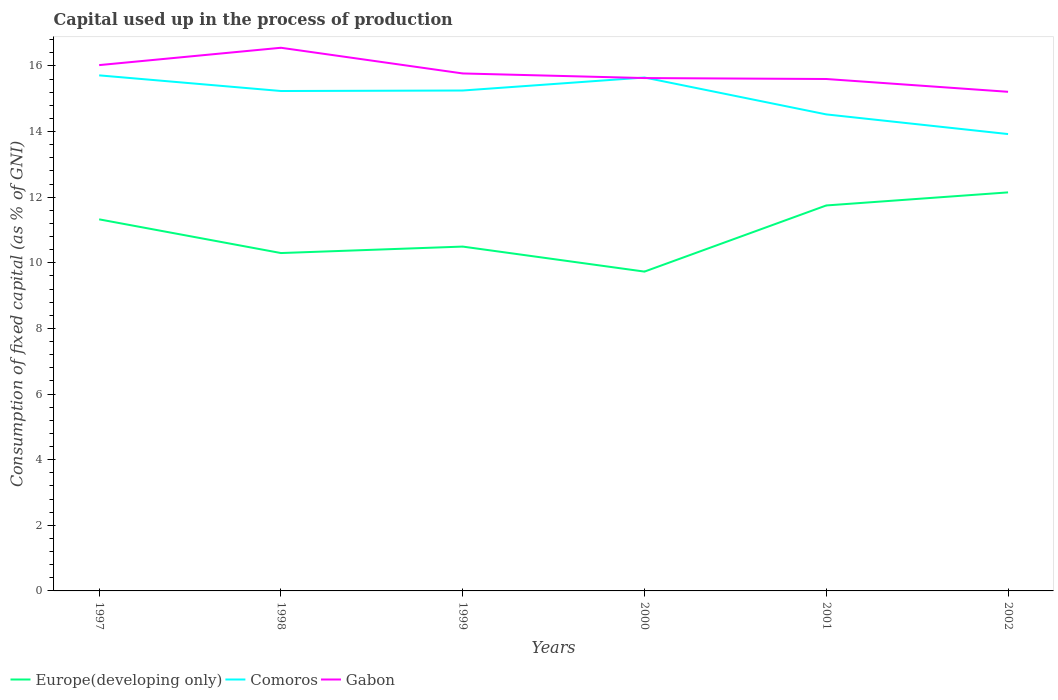Does the line corresponding to Europe(developing only) intersect with the line corresponding to Comoros?
Make the answer very short. No. Is the number of lines equal to the number of legend labels?
Provide a succinct answer. Yes. Across all years, what is the maximum capital used up in the process of production in Comoros?
Provide a short and direct response. 13.93. What is the total capital used up in the process of production in Europe(developing only) in the graph?
Provide a succinct answer. 0.57. What is the difference between the highest and the second highest capital used up in the process of production in Europe(developing only)?
Keep it short and to the point. 2.41. What is the difference between two consecutive major ticks on the Y-axis?
Your answer should be very brief. 2. Are the values on the major ticks of Y-axis written in scientific E-notation?
Your answer should be very brief. No. What is the title of the graph?
Keep it short and to the point. Capital used up in the process of production. What is the label or title of the Y-axis?
Give a very brief answer. Consumption of fixed capital (as % of GNI). What is the Consumption of fixed capital (as % of GNI) of Europe(developing only) in 1997?
Provide a succinct answer. 11.33. What is the Consumption of fixed capital (as % of GNI) in Comoros in 1997?
Offer a very short reply. 15.71. What is the Consumption of fixed capital (as % of GNI) of Gabon in 1997?
Offer a very short reply. 16.03. What is the Consumption of fixed capital (as % of GNI) of Europe(developing only) in 1998?
Make the answer very short. 10.3. What is the Consumption of fixed capital (as % of GNI) in Comoros in 1998?
Ensure brevity in your answer.  15.24. What is the Consumption of fixed capital (as % of GNI) in Gabon in 1998?
Offer a very short reply. 16.56. What is the Consumption of fixed capital (as % of GNI) of Europe(developing only) in 1999?
Your response must be concise. 10.5. What is the Consumption of fixed capital (as % of GNI) in Comoros in 1999?
Give a very brief answer. 15.25. What is the Consumption of fixed capital (as % of GNI) in Gabon in 1999?
Make the answer very short. 15.77. What is the Consumption of fixed capital (as % of GNI) in Europe(developing only) in 2000?
Offer a very short reply. 9.73. What is the Consumption of fixed capital (as % of GNI) of Comoros in 2000?
Your answer should be compact. 15.65. What is the Consumption of fixed capital (as % of GNI) in Gabon in 2000?
Give a very brief answer. 15.63. What is the Consumption of fixed capital (as % of GNI) of Europe(developing only) in 2001?
Give a very brief answer. 11.75. What is the Consumption of fixed capital (as % of GNI) in Comoros in 2001?
Offer a terse response. 14.52. What is the Consumption of fixed capital (as % of GNI) in Gabon in 2001?
Provide a short and direct response. 15.6. What is the Consumption of fixed capital (as % of GNI) of Europe(developing only) in 2002?
Your response must be concise. 12.15. What is the Consumption of fixed capital (as % of GNI) of Comoros in 2002?
Your response must be concise. 13.93. What is the Consumption of fixed capital (as % of GNI) of Gabon in 2002?
Offer a terse response. 15.21. Across all years, what is the maximum Consumption of fixed capital (as % of GNI) of Europe(developing only)?
Provide a short and direct response. 12.15. Across all years, what is the maximum Consumption of fixed capital (as % of GNI) of Comoros?
Provide a succinct answer. 15.71. Across all years, what is the maximum Consumption of fixed capital (as % of GNI) of Gabon?
Provide a short and direct response. 16.56. Across all years, what is the minimum Consumption of fixed capital (as % of GNI) of Europe(developing only)?
Provide a succinct answer. 9.73. Across all years, what is the minimum Consumption of fixed capital (as % of GNI) of Comoros?
Provide a succinct answer. 13.93. Across all years, what is the minimum Consumption of fixed capital (as % of GNI) in Gabon?
Your answer should be compact. 15.21. What is the total Consumption of fixed capital (as % of GNI) in Europe(developing only) in the graph?
Offer a very short reply. 65.75. What is the total Consumption of fixed capital (as % of GNI) in Comoros in the graph?
Ensure brevity in your answer.  90.3. What is the total Consumption of fixed capital (as % of GNI) in Gabon in the graph?
Provide a succinct answer. 94.8. What is the difference between the Consumption of fixed capital (as % of GNI) in Europe(developing only) in 1997 and that in 1998?
Offer a very short reply. 1.03. What is the difference between the Consumption of fixed capital (as % of GNI) in Comoros in 1997 and that in 1998?
Provide a short and direct response. 0.48. What is the difference between the Consumption of fixed capital (as % of GNI) in Gabon in 1997 and that in 1998?
Ensure brevity in your answer.  -0.53. What is the difference between the Consumption of fixed capital (as % of GNI) in Europe(developing only) in 1997 and that in 1999?
Give a very brief answer. 0.83. What is the difference between the Consumption of fixed capital (as % of GNI) of Comoros in 1997 and that in 1999?
Provide a short and direct response. 0.46. What is the difference between the Consumption of fixed capital (as % of GNI) in Gabon in 1997 and that in 1999?
Your answer should be very brief. 0.25. What is the difference between the Consumption of fixed capital (as % of GNI) of Europe(developing only) in 1997 and that in 2000?
Your answer should be compact. 1.59. What is the difference between the Consumption of fixed capital (as % of GNI) of Comoros in 1997 and that in 2000?
Your answer should be very brief. 0.07. What is the difference between the Consumption of fixed capital (as % of GNI) of Gabon in 1997 and that in 2000?
Give a very brief answer. 0.39. What is the difference between the Consumption of fixed capital (as % of GNI) of Europe(developing only) in 1997 and that in 2001?
Offer a terse response. -0.42. What is the difference between the Consumption of fixed capital (as % of GNI) of Comoros in 1997 and that in 2001?
Ensure brevity in your answer.  1.19. What is the difference between the Consumption of fixed capital (as % of GNI) of Gabon in 1997 and that in 2001?
Your answer should be very brief. 0.42. What is the difference between the Consumption of fixed capital (as % of GNI) in Europe(developing only) in 1997 and that in 2002?
Give a very brief answer. -0.82. What is the difference between the Consumption of fixed capital (as % of GNI) of Comoros in 1997 and that in 2002?
Your answer should be very brief. 1.79. What is the difference between the Consumption of fixed capital (as % of GNI) of Gabon in 1997 and that in 2002?
Your answer should be compact. 0.81. What is the difference between the Consumption of fixed capital (as % of GNI) of Europe(developing only) in 1998 and that in 1999?
Keep it short and to the point. -0.2. What is the difference between the Consumption of fixed capital (as % of GNI) of Comoros in 1998 and that in 1999?
Make the answer very short. -0.02. What is the difference between the Consumption of fixed capital (as % of GNI) in Gabon in 1998 and that in 1999?
Your answer should be very brief. 0.78. What is the difference between the Consumption of fixed capital (as % of GNI) of Europe(developing only) in 1998 and that in 2000?
Ensure brevity in your answer.  0.57. What is the difference between the Consumption of fixed capital (as % of GNI) of Comoros in 1998 and that in 2000?
Provide a short and direct response. -0.41. What is the difference between the Consumption of fixed capital (as % of GNI) of Gabon in 1998 and that in 2000?
Ensure brevity in your answer.  0.92. What is the difference between the Consumption of fixed capital (as % of GNI) in Europe(developing only) in 1998 and that in 2001?
Keep it short and to the point. -1.45. What is the difference between the Consumption of fixed capital (as % of GNI) of Comoros in 1998 and that in 2001?
Your answer should be very brief. 0.71. What is the difference between the Consumption of fixed capital (as % of GNI) of Europe(developing only) in 1998 and that in 2002?
Ensure brevity in your answer.  -1.85. What is the difference between the Consumption of fixed capital (as % of GNI) of Comoros in 1998 and that in 2002?
Provide a short and direct response. 1.31. What is the difference between the Consumption of fixed capital (as % of GNI) in Gabon in 1998 and that in 2002?
Give a very brief answer. 1.34. What is the difference between the Consumption of fixed capital (as % of GNI) in Europe(developing only) in 1999 and that in 2000?
Your response must be concise. 0.76. What is the difference between the Consumption of fixed capital (as % of GNI) of Comoros in 1999 and that in 2000?
Your response must be concise. -0.4. What is the difference between the Consumption of fixed capital (as % of GNI) of Gabon in 1999 and that in 2000?
Offer a terse response. 0.14. What is the difference between the Consumption of fixed capital (as % of GNI) of Europe(developing only) in 1999 and that in 2001?
Make the answer very short. -1.25. What is the difference between the Consumption of fixed capital (as % of GNI) of Comoros in 1999 and that in 2001?
Your response must be concise. 0.73. What is the difference between the Consumption of fixed capital (as % of GNI) in Gabon in 1999 and that in 2001?
Ensure brevity in your answer.  0.17. What is the difference between the Consumption of fixed capital (as % of GNI) of Europe(developing only) in 1999 and that in 2002?
Provide a succinct answer. -1.65. What is the difference between the Consumption of fixed capital (as % of GNI) in Comoros in 1999 and that in 2002?
Provide a succinct answer. 1.33. What is the difference between the Consumption of fixed capital (as % of GNI) of Gabon in 1999 and that in 2002?
Ensure brevity in your answer.  0.56. What is the difference between the Consumption of fixed capital (as % of GNI) of Europe(developing only) in 2000 and that in 2001?
Give a very brief answer. -2.02. What is the difference between the Consumption of fixed capital (as % of GNI) in Comoros in 2000 and that in 2001?
Offer a very short reply. 1.12. What is the difference between the Consumption of fixed capital (as % of GNI) of Gabon in 2000 and that in 2001?
Your answer should be compact. 0.03. What is the difference between the Consumption of fixed capital (as % of GNI) of Europe(developing only) in 2000 and that in 2002?
Provide a short and direct response. -2.41. What is the difference between the Consumption of fixed capital (as % of GNI) in Comoros in 2000 and that in 2002?
Offer a terse response. 1.72. What is the difference between the Consumption of fixed capital (as % of GNI) in Gabon in 2000 and that in 2002?
Provide a succinct answer. 0.42. What is the difference between the Consumption of fixed capital (as % of GNI) of Europe(developing only) in 2001 and that in 2002?
Your answer should be very brief. -0.4. What is the difference between the Consumption of fixed capital (as % of GNI) of Comoros in 2001 and that in 2002?
Make the answer very short. 0.6. What is the difference between the Consumption of fixed capital (as % of GNI) of Gabon in 2001 and that in 2002?
Your answer should be very brief. 0.39. What is the difference between the Consumption of fixed capital (as % of GNI) in Europe(developing only) in 1997 and the Consumption of fixed capital (as % of GNI) in Comoros in 1998?
Make the answer very short. -3.91. What is the difference between the Consumption of fixed capital (as % of GNI) in Europe(developing only) in 1997 and the Consumption of fixed capital (as % of GNI) in Gabon in 1998?
Your response must be concise. -5.23. What is the difference between the Consumption of fixed capital (as % of GNI) of Comoros in 1997 and the Consumption of fixed capital (as % of GNI) of Gabon in 1998?
Ensure brevity in your answer.  -0.84. What is the difference between the Consumption of fixed capital (as % of GNI) of Europe(developing only) in 1997 and the Consumption of fixed capital (as % of GNI) of Comoros in 1999?
Your answer should be compact. -3.93. What is the difference between the Consumption of fixed capital (as % of GNI) of Europe(developing only) in 1997 and the Consumption of fixed capital (as % of GNI) of Gabon in 1999?
Ensure brevity in your answer.  -4.45. What is the difference between the Consumption of fixed capital (as % of GNI) of Comoros in 1997 and the Consumption of fixed capital (as % of GNI) of Gabon in 1999?
Provide a succinct answer. -0.06. What is the difference between the Consumption of fixed capital (as % of GNI) of Europe(developing only) in 1997 and the Consumption of fixed capital (as % of GNI) of Comoros in 2000?
Provide a short and direct response. -4.32. What is the difference between the Consumption of fixed capital (as % of GNI) in Europe(developing only) in 1997 and the Consumption of fixed capital (as % of GNI) in Gabon in 2000?
Your response must be concise. -4.31. What is the difference between the Consumption of fixed capital (as % of GNI) of Comoros in 1997 and the Consumption of fixed capital (as % of GNI) of Gabon in 2000?
Give a very brief answer. 0.08. What is the difference between the Consumption of fixed capital (as % of GNI) in Europe(developing only) in 1997 and the Consumption of fixed capital (as % of GNI) in Comoros in 2001?
Ensure brevity in your answer.  -3.2. What is the difference between the Consumption of fixed capital (as % of GNI) in Europe(developing only) in 1997 and the Consumption of fixed capital (as % of GNI) in Gabon in 2001?
Provide a succinct answer. -4.28. What is the difference between the Consumption of fixed capital (as % of GNI) of Comoros in 1997 and the Consumption of fixed capital (as % of GNI) of Gabon in 2001?
Provide a short and direct response. 0.11. What is the difference between the Consumption of fixed capital (as % of GNI) in Europe(developing only) in 1997 and the Consumption of fixed capital (as % of GNI) in Comoros in 2002?
Keep it short and to the point. -2.6. What is the difference between the Consumption of fixed capital (as % of GNI) in Europe(developing only) in 1997 and the Consumption of fixed capital (as % of GNI) in Gabon in 2002?
Keep it short and to the point. -3.89. What is the difference between the Consumption of fixed capital (as % of GNI) in Comoros in 1997 and the Consumption of fixed capital (as % of GNI) in Gabon in 2002?
Your response must be concise. 0.5. What is the difference between the Consumption of fixed capital (as % of GNI) in Europe(developing only) in 1998 and the Consumption of fixed capital (as % of GNI) in Comoros in 1999?
Make the answer very short. -4.95. What is the difference between the Consumption of fixed capital (as % of GNI) in Europe(developing only) in 1998 and the Consumption of fixed capital (as % of GNI) in Gabon in 1999?
Give a very brief answer. -5.47. What is the difference between the Consumption of fixed capital (as % of GNI) in Comoros in 1998 and the Consumption of fixed capital (as % of GNI) in Gabon in 1999?
Keep it short and to the point. -0.54. What is the difference between the Consumption of fixed capital (as % of GNI) of Europe(developing only) in 1998 and the Consumption of fixed capital (as % of GNI) of Comoros in 2000?
Make the answer very short. -5.35. What is the difference between the Consumption of fixed capital (as % of GNI) in Europe(developing only) in 1998 and the Consumption of fixed capital (as % of GNI) in Gabon in 2000?
Provide a succinct answer. -5.33. What is the difference between the Consumption of fixed capital (as % of GNI) of Comoros in 1998 and the Consumption of fixed capital (as % of GNI) of Gabon in 2000?
Provide a succinct answer. -0.39. What is the difference between the Consumption of fixed capital (as % of GNI) of Europe(developing only) in 1998 and the Consumption of fixed capital (as % of GNI) of Comoros in 2001?
Your answer should be very brief. -4.23. What is the difference between the Consumption of fixed capital (as % of GNI) of Europe(developing only) in 1998 and the Consumption of fixed capital (as % of GNI) of Gabon in 2001?
Provide a short and direct response. -5.31. What is the difference between the Consumption of fixed capital (as % of GNI) of Comoros in 1998 and the Consumption of fixed capital (as % of GNI) of Gabon in 2001?
Your response must be concise. -0.37. What is the difference between the Consumption of fixed capital (as % of GNI) in Europe(developing only) in 1998 and the Consumption of fixed capital (as % of GNI) in Comoros in 2002?
Offer a very short reply. -3.63. What is the difference between the Consumption of fixed capital (as % of GNI) in Europe(developing only) in 1998 and the Consumption of fixed capital (as % of GNI) in Gabon in 2002?
Your answer should be compact. -4.92. What is the difference between the Consumption of fixed capital (as % of GNI) in Comoros in 1998 and the Consumption of fixed capital (as % of GNI) in Gabon in 2002?
Make the answer very short. 0.02. What is the difference between the Consumption of fixed capital (as % of GNI) in Europe(developing only) in 1999 and the Consumption of fixed capital (as % of GNI) in Comoros in 2000?
Offer a terse response. -5.15. What is the difference between the Consumption of fixed capital (as % of GNI) of Europe(developing only) in 1999 and the Consumption of fixed capital (as % of GNI) of Gabon in 2000?
Your response must be concise. -5.14. What is the difference between the Consumption of fixed capital (as % of GNI) in Comoros in 1999 and the Consumption of fixed capital (as % of GNI) in Gabon in 2000?
Provide a succinct answer. -0.38. What is the difference between the Consumption of fixed capital (as % of GNI) of Europe(developing only) in 1999 and the Consumption of fixed capital (as % of GNI) of Comoros in 2001?
Your answer should be compact. -4.03. What is the difference between the Consumption of fixed capital (as % of GNI) of Europe(developing only) in 1999 and the Consumption of fixed capital (as % of GNI) of Gabon in 2001?
Your answer should be compact. -5.11. What is the difference between the Consumption of fixed capital (as % of GNI) in Comoros in 1999 and the Consumption of fixed capital (as % of GNI) in Gabon in 2001?
Your answer should be compact. -0.35. What is the difference between the Consumption of fixed capital (as % of GNI) in Europe(developing only) in 1999 and the Consumption of fixed capital (as % of GNI) in Comoros in 2002?
Ensure brevity in your answer.  -3.43. What is the difference between the Consumption of fixed capital (as % of GNI) in Europe(developing only) in 1999 and the Consumption of fixed capital (as % of GNI) in Gabon in 2002?
Ensure brevity in your answer.  -4.72. What is the difference between the Consumption of fixed capital (as % of GNI) in Comoros in 1999 and the Consumption of fixed capital (as % of GNI) in Gabon in 2002?
Provide a short and direct response. 0.04. What is the difference between the Consumption of fixed capital (as % of GNI) of Europe(developing only) in 2000 and the Consumption of fixed capital (as % of GNI) of Comoros in 2001?
Make the answer very short. -4.79. What is the difference between the Consumption of fixed capital (as % of GNI) in Europe(developing only) in 2000 and the Consumption of fixed capital (as % of GNI) in Gabon in 2001?
Provide a short and direct response. -5.87. What is the difference between the Consumption of fixed capital (as % of GNI) of Comoros in 2000 and the Consumption of fixed capital (as % of GNI) of Gabon in 2001?
Your answer should be compact. 0.05. What is the difference between the Consumption of fixed capital (as % of GNI) of Europe(developing only) in 2000 and the Consumption of fixed capital (as % of GNI) of Comoros in 2002?
Your answer should be compact. -4.19. What is the difference between the Consumption of fixed capital (as % of GNI) of Europe(developing only) in 2000 and the Consumption of fixed capital (as % of GNI) of Gabon in 2002?
Your answer should be compact. -5.48. What is the difference between the Consumption of fixed capital (as % of GNI) of Comoros in 2000 and the Consumption of fixed capital (as % of GNI) of Gabon in 2002?
Your answer should be very brief. 0.44. What is the difference between the Consumption of fixed capital (as % of GNI) in Europe(developing only) in 2001 and the Consumption of fixed capital (as % of GNI) in Comoros in 2002?
Make the answer very short. -2.18. What is the difference between the Consumption of fixed capital (as % of GNI) in Europe(developing only) in 2001 and the Consumption of fixed capital (as % of GNI) in Gabon in 2002?
Provide a short and direct response. -3.46. What is the difference between the Consumption of fixed capital (as % of GNI) of Comoros in 2001 and the Consumption of fixed capital (as % of GNI) of Gabon in 2002?
Provide a succinct answer. -0.69. What is the average Consumption of fixed capital (as % of GNI) in Europe(developing only) per year?
Your response must be concise. 10.96. What is the average Consumption of fixed capital (as % of GNI) in Comoros per year?
Offer a terse response. 15.05. What is the average Consumption of fixed capital (as % of GNI) of Gabon per year?
Your answer should be very brief. 15.8. In the year 1997, what is the difference between the Consumption of fixed capital (as % of GNI) in Europe(developing only) and Consumption of fixed capital (as % of GNI) in Comoros?
Your answer should be very brief. -4.39. In the year 1997, what is the difference between the Consumption of fixed capital (as % of GNI) in Europe(developing only) and Consumption of fixed capital (as % of GNI) in Gabon?
Your response must be concise. -4.7. In the year 1997, what is the difference between the Consumption of fixed capital (as % of GNI) in Comoros and Consumption of fixed capital (as % of GNI) in Gabon?
Provide a short and direct response. -0.31. In the year 1998, what is the difference between the Consumption of fixed capital (as % of GNI) in Europe(developing only) and Consumption of fixed capital (as % of GNI) in Comoros?
Offer a very short reply. -4.94. In the year 1998, what is the difference between the Consumption of fixed capital (as % of GNI) of Europe(developing only) and Consumption of fixed capital (as % of GNI) of Gabon?
Provide a succinct answer. -6.26. In the year 1998, what is the difference between the Consumption of fixed capital (as % of GNI) in Comoros and Consumption of fixed capital (as % of GNI) in Gabon?
Provide a succinct answer. -1.32. In the year 1999, what is the difference between the Consumption of fixed capital (as % of GNI) of Europe(developing only) and Consumption of fixed capital (as % of GNI) of Comoros?
Keep it short and to the point. -4.76. In the year 1999, what is the difference between the Consumption of fixed capital (as % of GNI) in Europe(developing only) and Consumption of fixed capital (as % of GNI) in Gabon?
Provide a succinct answer. -5.28. In the year 1999, what is the difference between the Consumption of fixed capital (as % of GNI) in Comoros and Consumption of fixed capital (as % of GNI) in Gabon?
Your answer should be compact. -0.52. In the year 2000, what is the difference between the Consumption of fixed capital (as % of GNI) of Europe(developing only) and Consumption of fixed capital (as % of GNI) of Comoros?
Your response must be concise. -5.92. In the year 2000, what is the difference between the Consumption of fixed capital (as % of GNI) in Europe(developing only) and Consumption of fixed capital (as % of GNI) in Gabon?
Your answer should be very brief. -5.9. In the year 2000, what is the difference between the Consumption of fixed capital (as % of GNI) of Comoros and Consumption of fixed capital (as % of GNI) of Gabon?
Your answer should be compact. 0.02. In the year 2001, what is the difference between the Consumption of fixed capital (as % of GNI) in Europe(developing only) and Consumption of fixed capital (as % of GNI) in Comoros?
Keep it short and to the point. -2.78. In the year 2001, what is the difference between the Consumption of fixed capital (as % of GNI) of Europe(developing only) and Consumption of fixed capital (as % of GNI) of Gabon?
Provide a succinct answer. -3.85. In the year 2001, what is the difference between the Consumption of fixed capital (as % of GNI) of Comoros and Consumption of fixed capital (as % of GNI) of Gabon?
Offer a terse response. -1.08. In the year 2002, what is the difference between the Consumption of fixed capital (as % of GNI) in Europe(developing only) and Consumption of fixed capital (as % of GNI) in Comoros?
Your response must be concise. -1.78. In the year 2002, what is the difference between the Consumption of fixed capital (as % of GNI) of Europe(developing only) and Consumption of fixed capital (as % of GNI) of Gabon?
Provide a succinct answer. -3.07. In the year 2002, what is the difference between the Consumption of fixed capital (as % of GNI) of Comoros and Consumption of fixed capital (as % of GNI) of Gabon?
Your response must be concise. -1.29. What is the ratio of the Consumption of fixed capital (as % of GNI) of Europe(developing only) in 1997 to that in 1998?
Your answer should be very brief. 1.1. What is the ratio of the Consumption of fixed capital (as % of GNI) of Comoros in 1997 to that in 1998?
Keep it short and to the point. 1.03. What is the ratio of the Consumption of fixed capital (as % of GNI) in Gabon in 1997 to that in 1998?
Keep it short and to the point. 0.97. What is the ratio of the Consumption of fixed capital (as % of GNI) of Europe(developing only) in 1997 to that in 1999?
Your response must be concise. 1.08. What is the ratio of the Consumption of fixed capital (as % of GNI) in Comoros in 1997 to that in 1999?
Provide a succinct answer. 1.03. What is the ratio of the Consumption of fixed capital (as % of GNI) of Gabon in 1997 to that in 1999?
Give a very brief answer. 1.02. What is the ratio of the Consumption of fixed capital (as % of GNI) of Europe(developing only) in 1997 to that in 2000?
Ensure brevity in your answer.  1.16. What is the ratio of the Consumption of fixed capital (as % of GNI) of Comoros in 1997 to that in 2000?
Ensure brevity in your answer.  1. What is the ratio of the Consumption of fixed capital (as % of GNI) in Gabon in 1997 to that in 2000?
Provide a succinct answer. 1.03. What is the ratio of the Consumption of fixed capital (as % of GNI) in Comoros in 1997 to that in 2001?
Offer a terse response. 1.08. What is the ratio of the Consumption of fixed capital (as % of GNI) in Gabon in 1997 to that in 2001?
Ensure brevity in your answer.  1.03. What is the ratio of the Consumption of fixed capital (as % of GNI) of Europe(developing only) in 1997 to that in 2002?
Provide a short and direct response. 0.93. What is the ratio of the Consumption of fixed capital (as % of GNI) of Comoros in 1997 to that in 2002?
Keep it short and to the point. 1.13. What is the ratio of the Consumption of fixed capital (as % of GNI) in Gabon in 1997 to that in 2002?
Make the answer very short. 1.05. What is the ratio of the Consumption of fixed capital (as % of GNI) of Europe(developing only) in 1998 to that in 1999?
Give a very brief answer. 0.98. What is the ratio of the Consumption of fixed capital (as % of GNI) in Gabon in 1998 to that in 1999?
Your answer should be very brief. 1.05. What is the ratio of the Consumption of fixed capital (as % of GNI) in Europe(developing only) in 1998 to that in 2000?
Provide a succinct answer. 1.06. What is the ratio of the Consumption of fixed capital (as % of GNI) of Comoros in 1998 to that in 2000?
Your response must be concise. 0.97. What is the ratio of the Consumption of fixed capital (as % of GNI) in Gabon in 1998 to that in 2000?
Your answer should be compact. 1.06. What is the ratio of the Consumption of fixed capital (as % of GNI) of Europe(developing only) in 1998 to that in 2001?
Provide a short and direct response. 0.88. What is the ratio of the Consumption of fixed capital (as % of GNI) in Comoros in 1998 to that in 2001?
Offer a very short reply. 1.05. What is the ratio of the Consumption of fixed capital (as % of GNI) in Gabon in 1998 to that in 2001?
Offer a terse response. 1.06. What is the ratio of the Consumption of fixed capital (as % of GNI) of Europe(developing only) in 1998 to that in 2002?
Your answer should be compact. 0.85. What is the ratio of the Consumption of fixed capital (as % of GNI) of Comoros in 1998 to that in 2002?
Your answer should be compact. 1.09. What is the ratio of the Consumption of fixed capital (as % of GNI) in Gabon in 1998 to that in 2002?
Keep it short and to the point. 1.09. What is the ratio of the Consumption of fixed capital (as % of GNI) of Europe(developing only) in 1999 to that in 2000?
Your answer should be very brief. 1.08. What is the ratio of the Consumption of fixed capital (as % of GNI) of Comoros in 1999 to that in 2000?
Offer a terse response. 0.97. What is the ratio of the Consumption of fixed capital (as % of GNI) of Gabon in 1999 to that in 2000?
Ensure brevity in your answer.  1.01. What is the ratio of the Consumption of fixed capital (as % of GNI) of Europe(developing only) in 1999 to that in 2001?
Provide a succinct answer. 0.89. What is the ratio of the Consumption of fixed capital (as % of GNI) in Comoros in 1999 to that in 2001?
Provide a succinct answer. 1.05. What is the ratio of the Consumption of fixed capital (as % of GNI) of Gabon in 1999 to that in 2001?
Provide a succinct answer. 1.01. What is the ratio of the Consumption of fixed capital (as % of GNI) in Europe(developing only) in 1999 to that in 2002?
Make the answer very short. 0.86. What is the ratio of the Consumption of fixed capital (as % of GNI) of Comoros in 1999 to that in 2002?
Offer a very short reply. 1.1. What is the ratio of the Consumption of fixed capital (as % of GNI) in Gabon in 1999 to that in 2002?
Your response must be concise. 1.04. What is the ratio of the Consumption of fixed capital (as % of GNI) in Europe(developing only) in 2000 to that in 2001?
Provide a succinct answer. 0.83. What is the ratio of the Consumption of fixed capital (as % of GNI) in Comoros in 2000 to that in 2001?
Ensure brevity in your answer.  1.08. What is the ratio of the Consumption of fixed capital (as % of GNI) of Europe(developing only) in 2000 to that in 2002?
Offer a very short reply. 0.8. What is the ratio of the Consumption of fixed capital (as % of GNI) in Comoros in 2000 to that in 2002?
Your response must be concise. 1.12. What is the ratio of the Consumption of fixed capital (as % of GNI) in Gabon in 2000 to that in 2002?
Your answer should be compact. 1.03. What is the ratio of the Consumption of fixed capital (as % of GNI) in Europe(developing only) in 2001 to that in 2002?
Offer a terse response. 0.97. What is the ratio of the Consumption of fixed capital (as % of GNI) of Comoros in 2001 to that in 2002?
Provide a succinct answer. 1.04. What is the ratio of the Consumption of fixed capital (as % of GNI) of Gabon in 2001 to that in 2002?
Your answer should be compact. 1.03. What is the difference between the highest and the second highest Consumption of fixed capital (as % of GNI) in Europe(developing only)?
Make the answer very short. 0.4. What is the difference between the highest and the second highest Consumption of fixed capital (as % of GNI) of Comoros?
Give a very brief answer. 0.07. What is the difference between the highest and the second highest Consumption of fixed capital (as % of GNI) of Gabon?
Offer a terse response. 0.53. What is the difference between the highest and the lowest Consumption of fixed capital (as % of GNI) in Europe(developing only)?
Offer a terse response. 2.41. What is the difference between the highest and the lowest Consumption of fixed capital (as % of GNI) of Comoros?
Offer a very short reply. 1.79. What is the difference between the highest and the lowest Consumption of fixed capital (as % of GNI) in Gabon?
Make the answer very short. 1.34. 